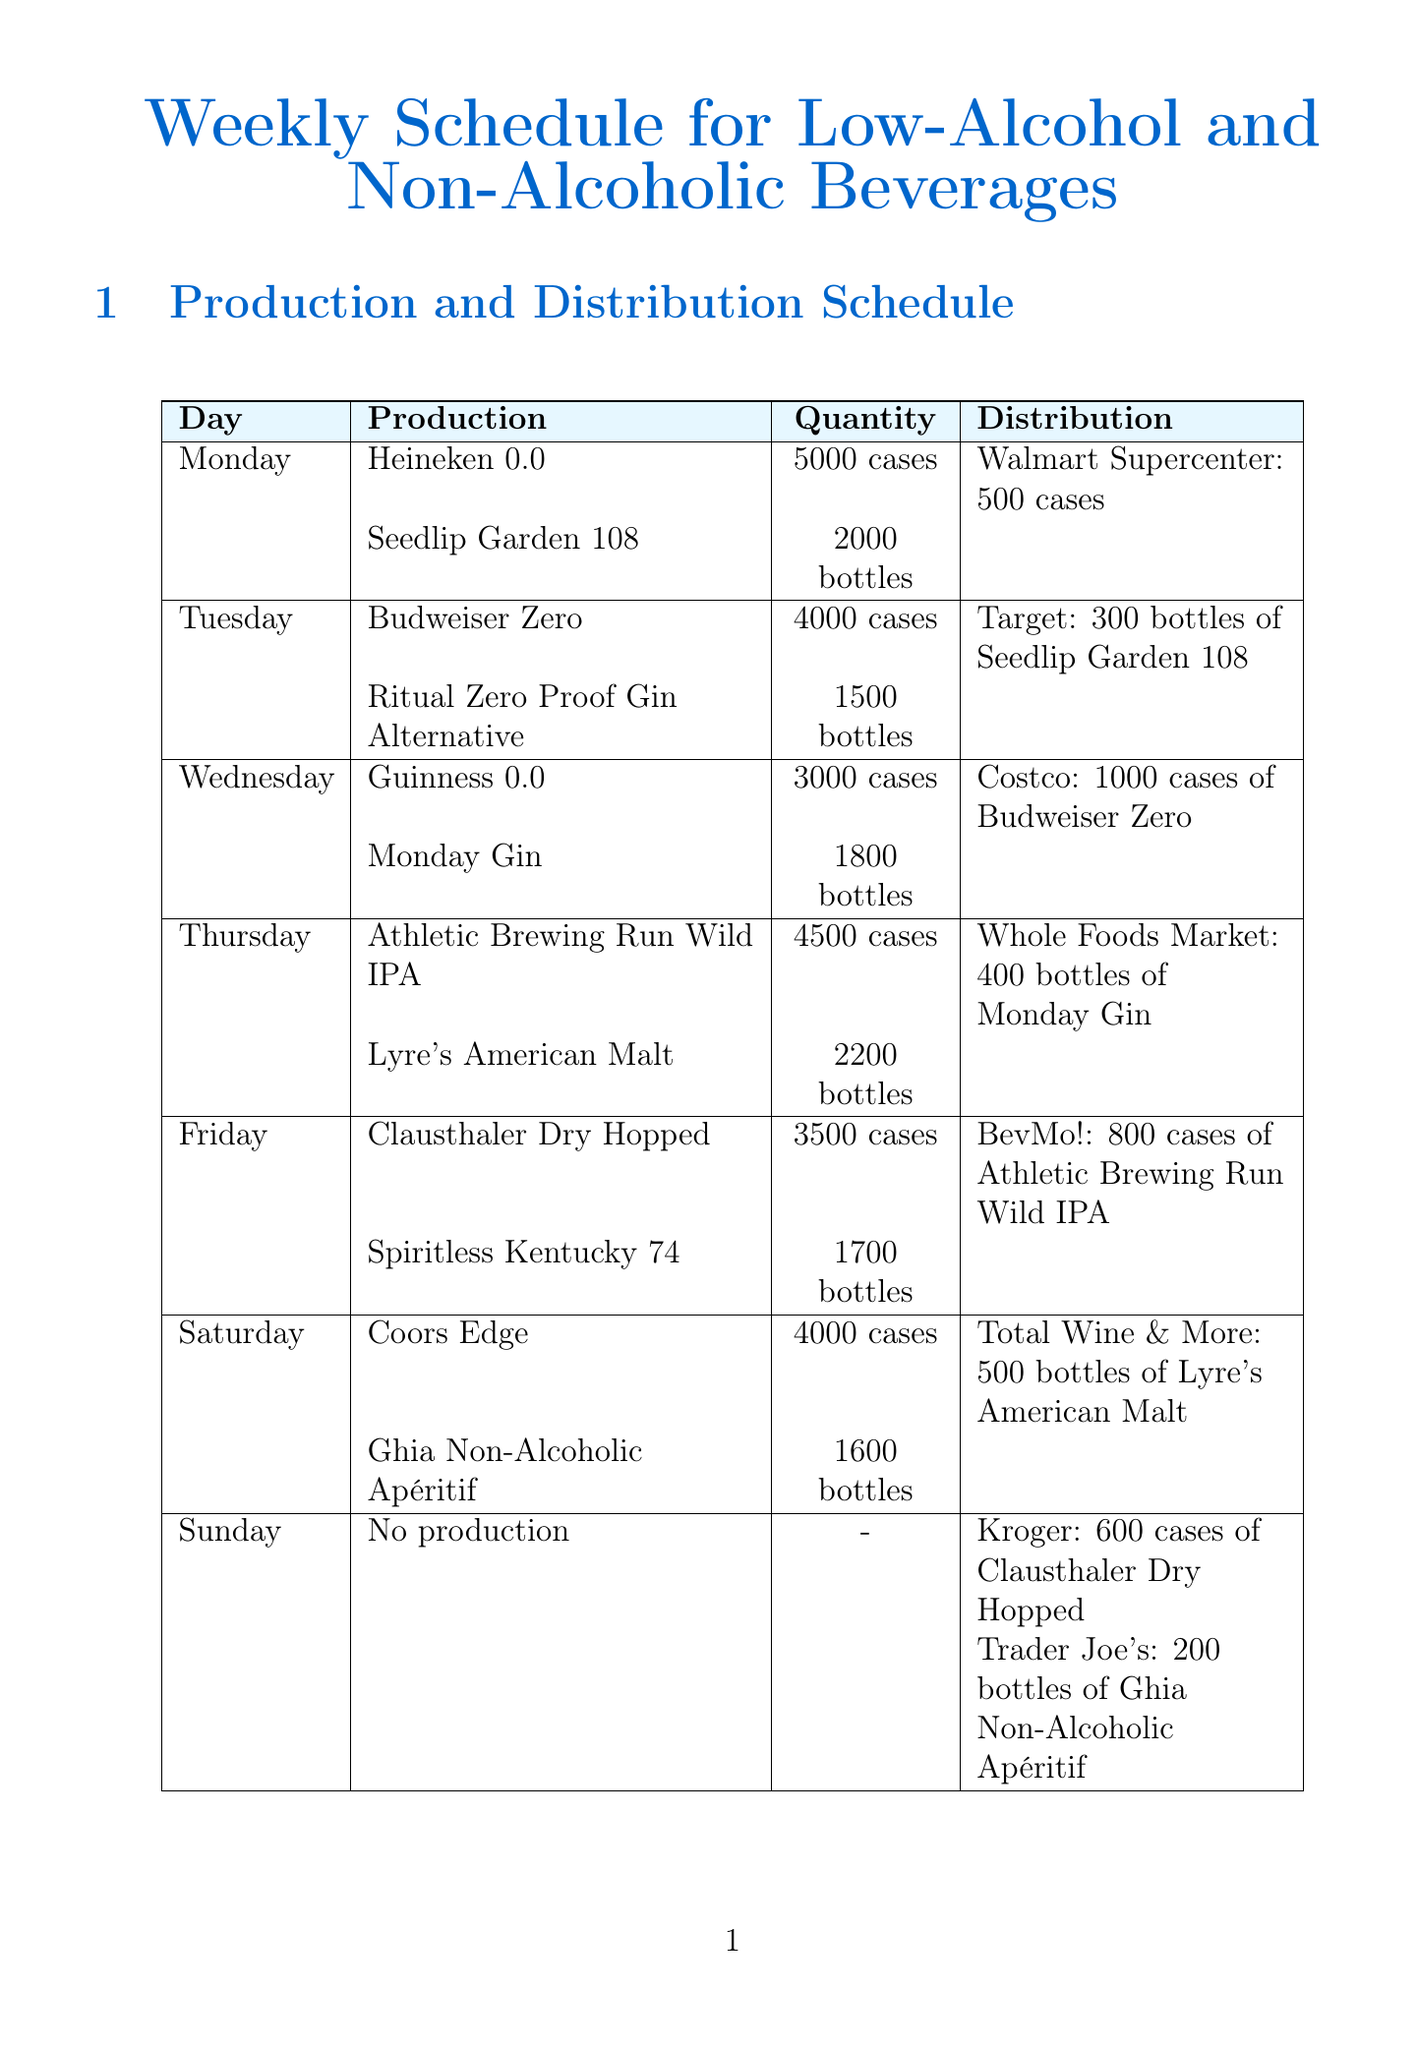What is the total production quantity of Heineken 0.0 for the week? The production quantity for Heineken 0.0 is 5000 cases on Monday. Since there are no other productions mentioned for this product on other days, the total remains the same.
Answer: 5000 cases On which day is the highest quantity of Clausthaler Dry Hopped produced? Clausthaler Dry Hopped is produced only on Friday with 3500 cases, which is the only reference given, making it the highest for that product.
Answer: 3500 cases Which product is being distributed to Trader Joe's? The document specifies that Trader Joe's receives Ghia Non-Alcoholic Apéritif with a quantity of 200 bottles on Sunday.
Answer: Ghia Non-Alcoholic Apéritif What is the frequency of microbial analysis in quality control measures? Weekly microbial analysis is specified as part of the quality control measures for all production lines.
Answer: Weekly Which beverage is scheduled for distribution at Costco on Wednesday? The distribution scheduled for Wednesday involves Budweiser Zero, with a quantity of 1000 cases going to Costco.
Answer: Budweiser Zero What sustainability initiative targets 50% recycled content? One of the sustainability initiatives mentioned is to use recycled materials in packaging, with a target of 50% recycled content by 2023.
Answer: 50% recycled content How many bottles of Ritual Zero Proof Gin Alternative are produced on Tuesday? The production quantity for Ritual Zero Proof Gin Alternative on Tuesday is 1500 bottles, as stated in the weekly schedule.
Answer: 1500 bottles What is the responsible team for daily taste testing? The quality control measure for daily taste testing is the responsibility of the Quality Assurance Team as indicated in the document.
Answer: Quality Assurance Team 